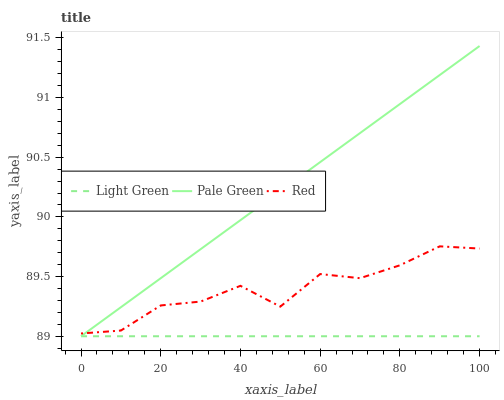Does Light Green have the minimum area under the curve?
Answer yes or no. Yes. Does Pale Green have the maximum area under the curve?
Answer yes or no. Yes. Does Red have the minimum area under the curve?
Answer yes or no. No. Does Red have the maximum area under the curve?
Answer yes or no. No. Is Light Green the smoothest?
Answer yes or no. Yes. Is Red the roughest?
Answer yes or no. Yes. Is Red the smoothest?
Answer yes or no. No. Is Light Green the roughest?
Answer yes or no. No. Does Pale Green have the lowest value?
Answer yes or no. Yes. Does Red have the lowest value?
Answer yes or no. No. Does Pale Green have the highest value?
Answer yes or no. Yes. Does Red have the highest value?
Answer yes or no. No. Is Light Green less than Red?
Answer yes or no. Yes. Is Red greater than Light Green?
Answer yes or no. Yes. Does Pale Green intersect Red?
Answer yes or no. Yes. Is Pale Green less than Red?
Answer yes or no. No. Is Pale Green greater than Red?
Answer yes or no. No. Does Light Green intersect Red?
Answer yes or no. No. 